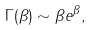<formula> <loc_0><loc_0><loc_500><loc_500>\Gamma ( \beta ) \sim \beta e ^ { \beta } ,</formula> 